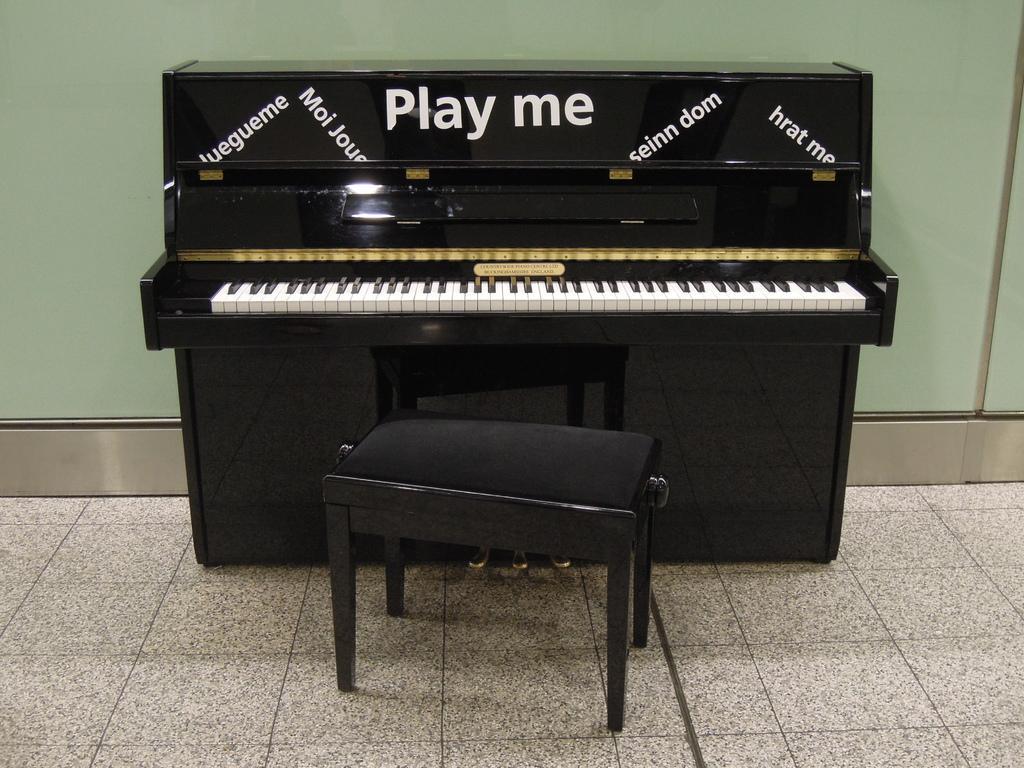Could you give a brief overview of what you see in this image? In this image i can see a piano and a stool on the floor. 